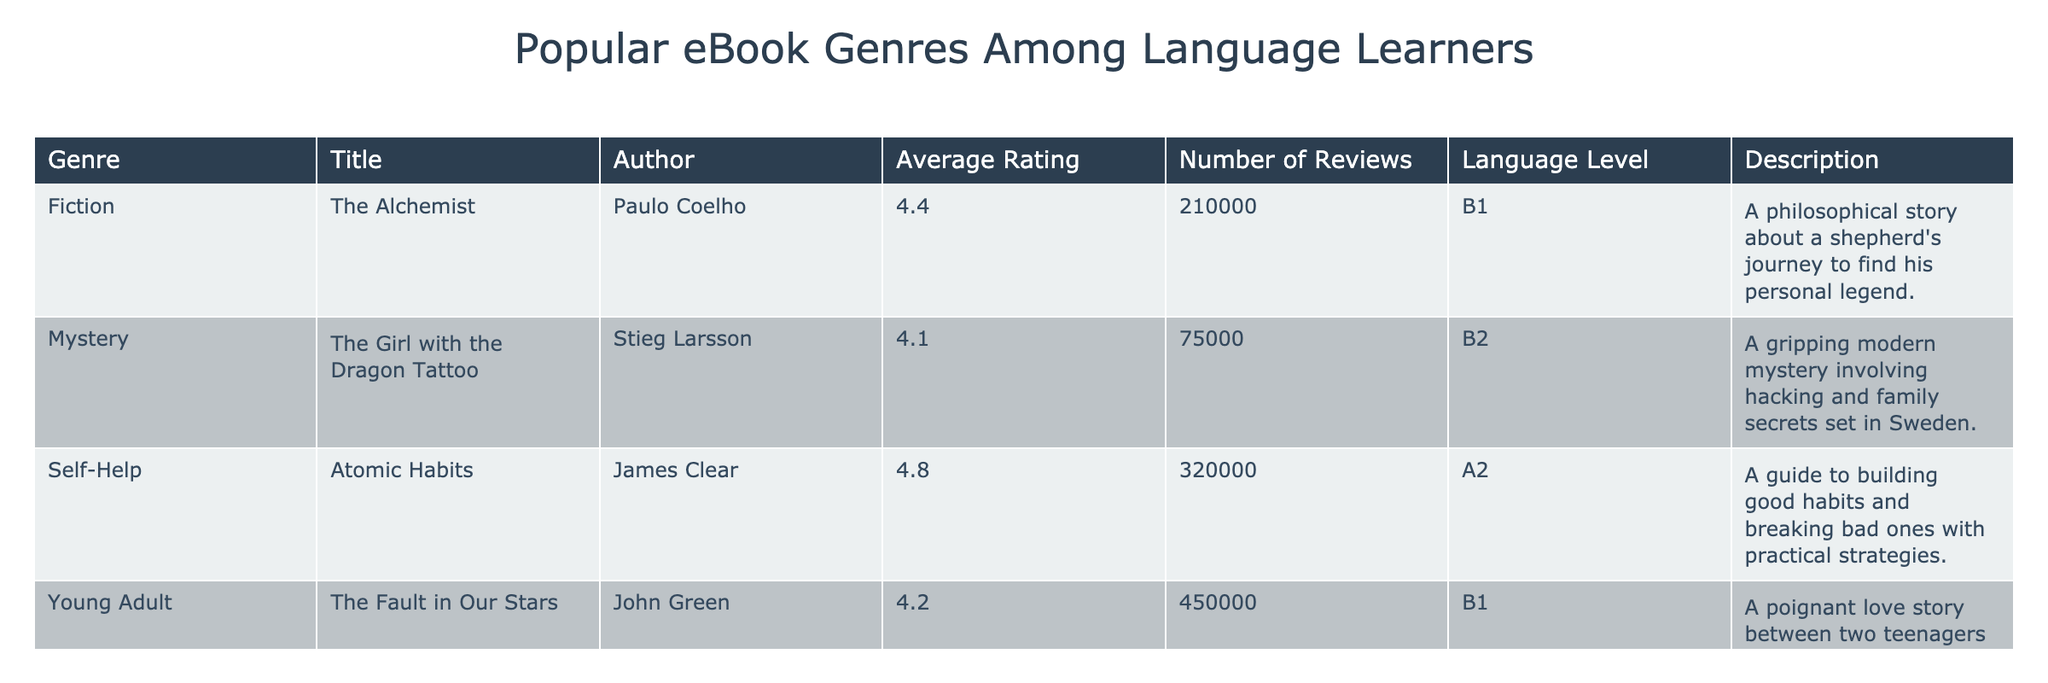What is the title of the eBook with the highest average rating? The average ratings are as follows: "The Alchemist" (4.4), "The Girl with the Dragon Tattoo" (4.1), "Atomic Habits" (4.8), "The Fault in Our Stars" (4.2), "Maus" (4.5), and "Pride and Prejudice" (4.3). The highest average rating is 4.8, belonging to "Atomic Habits."
Answer: Atomic Habits Which genre has the most number of reviews? The number of reviews per genre is: Fiction (210,000), Mystery (75,000), Self-Help (320,000), Young Adult (450,000), Graphic Novel (70,000), and Romance (150,000). The highest number of reviews is 450,000 for the genre Young Adult.
Answer: Young Adult Is the average rating of "Pride and Prejudice" higher than 4.0? The average rating of "Pride and Prejudice" is 4.3, which is greater than 4.0. Therefore, the statement is true.
Answer: Yes How many eBooks in the table have an average rating of 4.5 or higher? The eBooks with an average rating of 4.5 or higher are: "The Alchemist" (4.4), "Atomic Habits" (4.8), "Maus" (4.5), and "Pride and Prejudice" (4.3). This sums up to 3 eBooks.
Answer: 3 What is the difference in average ratings between "Atomic Habits" and "The Girl with the Dragon Tattoo"? The average rating of "Atomic Habits" is 4.8 and "The Girl with the Dragon Tattoo" is 4.1. The difference is calculated as 4.8 - 4.1 = 0.7.
Answer: 0.7 Which language level has the most eBooks listed? The language levels in the table are B1 (2 eBooks: "The Alchemist" and "The Fault in Our Stars"), B2 (1 eBook: "The Girl with the Dragon Tattoo"), A2 (2 eBooks: "Atomic Habits" and "Maus"), and A1 (1 eBook: "Pride and Prejudice"). The levels B1 and A2 each have the most eBooks listed at 2.
Answer: B1 and A2 What percentage of the total reviews comes from "Atomic Habits"? The total number of reviews is calculated by summing all the reviews: 210,000 + 75,000 + 320,000 + 450,000 + 70,000 + 150,000 = 1,275,000. "Atomic Habits" has 320,000 reviews. The percentage is (320,000 / 1,275,000) * 100 = 25.1%.
Answer: 25.1% Which book has the lowest rating, and what is that rating? The ratings are: "The Alchemist" (4.4), "The Girl with the Dragon Tattoo" (4.1), "Atomic Habits" (4.8), "The Fault in Our Stars" (4.2), "Maus" (4.5), and "Pride and Prejudice" (4.3). The lowest rating is 4.1 for "The Girl with the Dragon Tattoo."
Answer: The Girl with the Dragon Tattoo, 4.1 